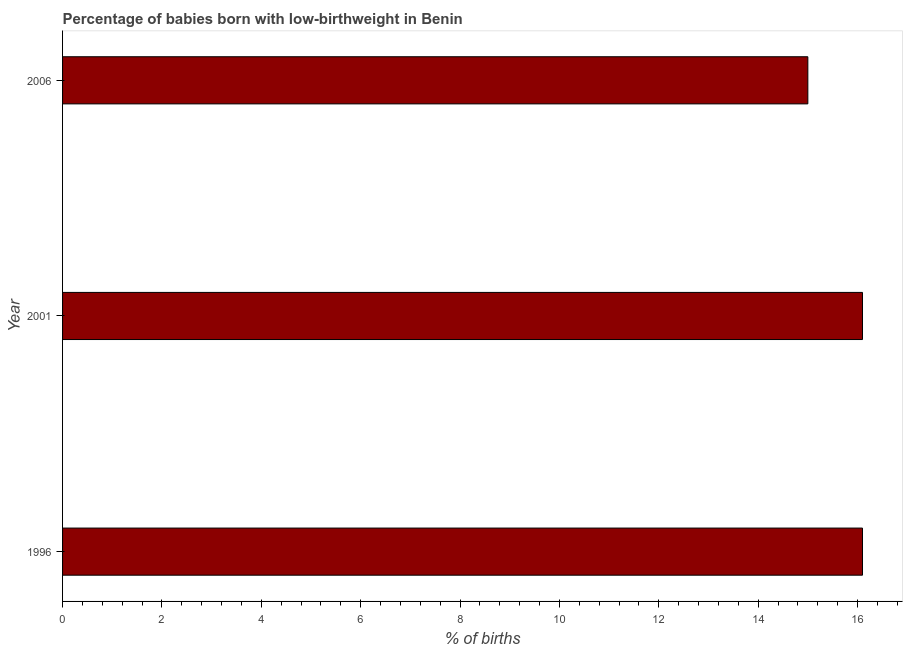Does the graph contain any zero values?
Your answer should be compact. No. Does the graph contain grids?
Ensure brevity in your answer.  No. What is the title of the graph?
Your response must be concise. Percentage of babies born with low-birthweight in Benin. What is the label or title of the X-axis?
Offer a terse response. % of births. What is the percentage of babies who were born with low-birthweight in 2001?
Your answer should be very brief. 16.1. Across all years, what is the minimum percentage of babies who were born with low-birthweight?
Provide a short and direct response. 15. What is the sum of the percentage of babies who were born with low-birthweight?
Provide a short and direct response. 47.2. What is the average percentage of babies who were born with low-birthweight per year?
Your answer should be very brief. 15.73. What is the difference between the highest and the second highest percentage of babies who were born with low-birthweight?
Make the answer very short. 0. Is the sum of the percentage of babies who were born with low-birthweight in 2001 and 2006 greater than the maximum percentage of babies who were born with low-birthweight across all years?
Ensure brevity in your answer.  Yes. What is the difference between the highest and the lowest percentage of babies who were born with low-birthweight?
Keep it short and to the point. 1.1. How many bars are there?
Give a very brief answer. 3. Are all the bars in the graph horizontal?
Provide a succinct answer. Yes. Are the values on the major ticks of X-axis written in scientific E-notation?
Offer a terse response. No. What is the % of births in 2001?
Make the answer very short. 16.1. What is the % of births in 2006?
Give a very brief answer. 15. What is the difference between the % of births in 1996 and 2001?
Keep it short and to the point. 0. What is the ratio of the % of births in 1996 to that in 2006?
Your answer should be very brief. 1.07. What is the ratio of the % of births in 2001 to that in 2006?
Your answer should be very brief. 1.07. 